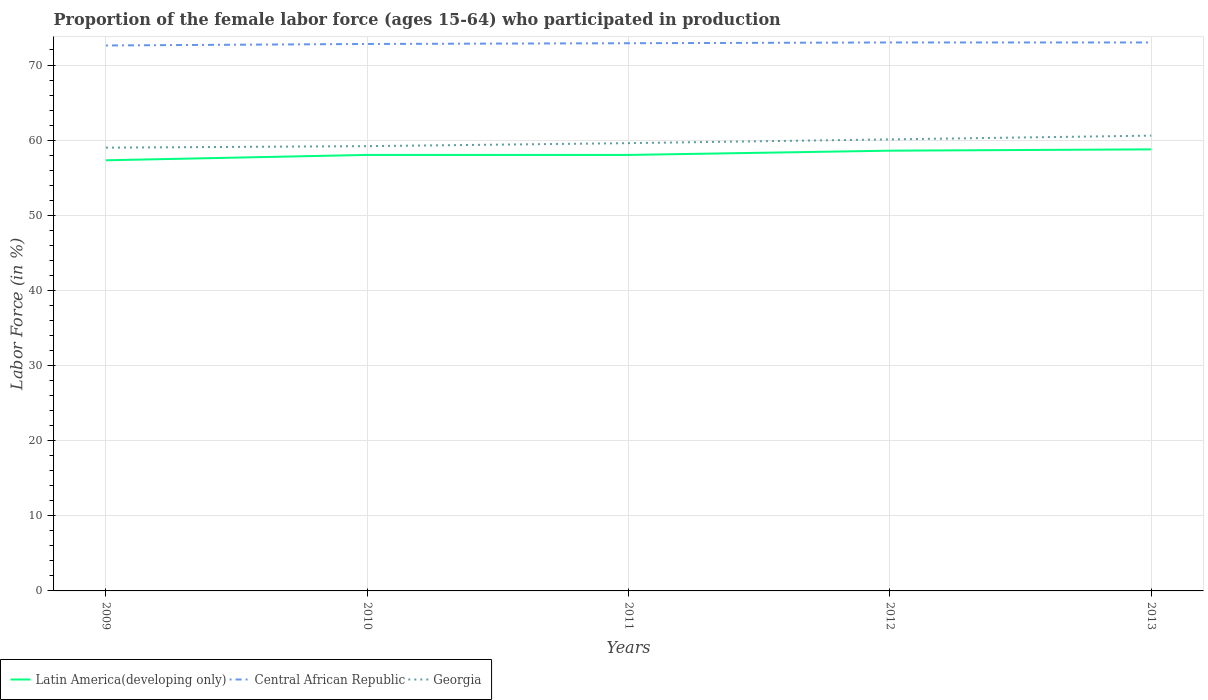Does the line corresponding to Central African Republic intersect with the line corresponding to Georgia?
Your answer should be compact. No. Is the number of lines equal to the number of legend labels?
Make the answer very short. Yes. Across all years, what is the maximum proportion of the female labor force who participated in production in Georgia?
Your answer should be compact. 59. In which year was the proportion of the female labor force who participated in production in Georgia maximum?
Provide a succinct answer. 2009. What is the total proportion of the female labor force who participated in production in Latin America(developing only) in the graph?
Offer a very short reply. -1.28. What is the difference between the highest and the second highest proportion of the female labor force who participated in production in Latin America(developing only)?
Keep it short and to the point. 1.45. How many years are there in the graph?
Provide a succinct answer. 5. Are the values on the major ticks of Y-axis written in scientific E-notation?
Offer a very short reply. No. Does the graph contain any zero values?
Keep it short and to the point. No. How many legend labels are there?
Your answer should be compact. 3. What is the title of the graph?
Your response must be concise. Proportion of the female labor force (ages 15-64) who participated in production. What is the label or title of the Y-axis?
Give a very brief answer. Labor Force (in %). What is the Labor Force (in %) of Latin America(developing only) in 2009?
Provide a succinct answer. 57.32. What is the Labor Force (in %) of Central African Republic in 2009?
Provide a succinct answer. 72.6. What is the Labor Force (in %) of Latin America(developing only) in 2010?
Keep it short and to the point. 58.03. What is the Labor Force (in %) of Central African Republic in 2010?
Provide a succinct answer. 72.8. What is the Labor Force (in %) in Georgia in 2010?
Offer a terse response. 59.2. What is the Labor Force (in %) of Latin America(developing only) in 2011?
Your response must be concise. 58.03. What is the Labor Force (in %) of Central African Republic in 2011?
Your answer should be compact. 72.9. What is the Labor Force (in %) of Georgia in 2011?
Your answer should be very brief. 59.6. What is the Labor Force (in %) in Latin America(developing only) in 2012?
Make the answer very short. 58.6. What is the Labor Force (in %) of Georgia in 2012?
Your answer should be very brief. 60.1. What is the Labor Force (in %) of Latin America(developing only) in 2013?
Make the answer very short. 58.77. What is the Labor Force (in %) in Central African Republic in 2013?
Ensure brevity in your answer.  73. What is the Labor Force (in %) of Georgia in 2013?
Provide a short and direct response. 60.6. Across all years, what is the maximum Labor Force (in %) in Latin America(developing only)?
Your response must be concise. 58.77. Across all years, what is the maximum Labor Force (in %) of Georgia?
Provide a short and direct response. 60.6. Across all years, what is the minimum Labor Force (in %) of Latin America(developing only)?
Provide a short and direct response. 57.32. Across all years, what is the minimum Labor Force (in %) in Central African Republic?
Provide a short and direct response. 72.6. What is the total Labor Force (in %) in Latin America(developing only) in the graph?
Provide a short and direct response. 290.75. What is the total Labor Force (in %) in Central African Republic in the graph?
Ensure brevity in your answer.  364.3. What is the total Labor Force (in %) in Georgia in the graph?
Make the answer very short. 298.5. What is the difference between the Labor Force (in %) in Latin America(developing only) in 2009 and that in 2010?
Your response must be concise. -0.71. What is the difference between the Labor Force (in %) of Latin America(developing only) in 2009 and that in 2011?
Offer a very short reply. -0.71. What is the difference between the Labor Force (in %) in Central African Republic in 2009 and that in 2011?
Ensure brevity in your answer.  -0.3. What is the difference between the Labor Force (in %) in Georgia in 2009 and that in 2011?
Keep it short and to the point. -0.6. What is the difference between the Labor Force (in %) of Latin America(developing only) in 2009 and that in 2012?
Keep it short and to the point. -1.28. What is the difference between the Labor Force (in %) of Georgia in 2009 and that in 2012?
Give a very brief answer. -1.1. What is the difference between the Labor Force (in %) of Latin America(developing only) in 2009 and that in 2013?
Keep it short and to the point. -1.45. What is the difference between the Labor Force (in %) in Central African Republic in 2009 and that in 2013?
Your answer should be very brief. -0.4. What is the difference between the Labor Force (in %) of Georgia in 2009 and that in 2013?
Make the answer very short. -1.6. What is the difference between the Labor Force (in %) of Latin America(developing only) in 2010 and that in 2011?
Provide a short and direct response. 0. What is the difference between the Labor Force (in %) in Central African Republic in 2010 and that in 2011?
Your answer should be compact. -0.1. What is the difference between the Labor Force (in %) of Georgia in 2010 and that in 2011?
Provide a short and direct response. -0.4. What is the difference between the Labor Force (in %) in Latin America(developing only) in 2010 and that in 2012?
Ensure brevity in your answer.  -0.57. What is the difference between the Labor Force (in %) of Latin America(developing only) in 2010 and that in 2013?
Provide a short and direct response. -0.74. What is the difference between the Labor Force (in %) in Central African Republic in 2010 and that in 2013?
Offer a terse response. -0.2. What is the difference between the Labor Force (in %) in Latin America(developing only) in 2011 and that in 2012?
Provide a succinct answer. -0.57. What is the difference between the Labor Force (in %) in Central African Republic in 2011 and that in 2012?
Ensure brevity in your answer.  -0.1. What is the difference between the Labor Force (in %) in Georgia in 2011 and that in 2012?
Make the answer very short. -0.5. What is the difference between the Labor Force (in %) of Latin America(developing only) in 2011 and that in 2013?
Keep it short and to the point. -0.74. What is the difference between the Labor Force (in %) in Georgia in 2011 and that in 2013?
Your response must be concise. -1. What is the difference between the Labor Force (in %) of Latin America(developing only) in 2012 and that in 2013?
Provide a succinct answer. -0.17. What is the difference between the Labor Force (in %) in Central African Republic in 2012 and that in 2013?
Offer a terse response. 0. What is the difference between the Labor Force (in %) in Latin America(developing only) in 2009 and the Labor Force (in %) in Central African Republic in 2010?
Your answer should be very brief. -15.48. What is the difference between the Labor Force (in %) of Latin America(developing only) in 2009 and the Labor Force (in %) of Georgia in 2010?
Offer a very short reply. -1.88. What is the difference between the Labor Force (in %) of Central African Republic in 2009 and the Labor Force (in %) of Georgia in 2010?
Your answer should be very brief. 13.4. What is the difference between the Labor Force (in %) in Latin America(developing only) in 2009 and the Labor Force (in %) in Central African Republic in 2011?
Offer a terse response. -15.58. What is the difference between the Labor Force (in %) of Latin America(developing only) in 2009 and the Labor Force (in %) of Georgia in 2011?
Provide a short and direct response. -2.28. What is the difference between the Labor Force (in %) of Latin America(developing only) in 2009 and the Labor Force (in %) of Central African Republic in 2012?
Your answer should be compact. -15.68. What is the difference between the Labor Force (in %) in Latin America(developing only) in 2009 and the Labor Force (in %) in Georgia in 2012?
Offer a terse response. -2.78. What is the difference between the Labor Force (in %) in Central African Republic in 2009 and the Labor Force (in %) in Georgia in 2012?
Ensure brevity in your answer.  12.5. What is the difference between the Labor Force (in %) of Latin America(developing only) in 2009 and the Labor Force (in %) of Central African Republic in 2013?
Ensure brevity in your answer.  -15.68. What is the difference between the Labor Force (in %) of Latin America(developing only) in 2009 and the Labor Force (in %) of Georgia in 2013?
Offer a very short reply. -3.28. What is the difference between the Labor Force (in %) in Central African Republic in 2009 and the Labor Force (in %) in Georgia in 2013?
Your answer should be very brief. 12. What is the difference between the Labor Force (in %) in Latin America(developing only) in 2010 and the Labor Force (in %) in Central African Republic in 2011?
Keep it short and to the point. -14.87. What is the difference between the Labor Force (in %) of Latin America(developing only) in 2010 and the Labor Force (in %) of Georgia in 2011?
Ensure brevity in your answer.  -1.57. What is the difference between the Labor Force (in %) of Latin America(developing only) in 2010 and the Labor Force (in %) of Central African Republic in 2012?
Offer a very short reply. -14.97. What is the difference between the Labor Force (in %) in Latin America(developing only) in 2010 and the Labor Force (in %) in Georgia in 2012?
Give a very brief answer. -2.07. What is the difference between the Labor Force (in %) in Central African Republic in 2010 and the Labor Force (in %) in Georgia in 2012?
Give a very brief answer. 12.7. What is the difference between the Labor Force (in %) in Latin America(developing only) in 2010 and the Labor Force (in %) in Central African Republic in 2013?
Your answer should be very brief. -14.97. What is the difference between the Labor Force (in %) of Latin America(developing only) in 2010 and the Labor Force (in %) of Georgia in 2013?
Offer a very short reply. -2.57. What is the difference between the Labor Force (in %) of Latin America(developing only) in 2011 and the Labor Force (in %) of Central African Republic in 2012?
Ensure brevity in your answer.  -14.97. What is the difference between the Labor Force (in %) in Latin America(developing only) in 2011 and the Labor Force (in %) in Georgia in 2012?
Provide a short and direct response. -2.07. What is the difference between the Labor Force (in %) in Latin America(developing only) in 2011 and the Labor Force (in %) in Central African Republic in 2013?
Ensure brevity in your answer.  -14.97. What is the difference between the Labor Force (in %) of Latin America(developing only) in 2011 and the Labor Force (in %) of Georgia in 2013?
Ensure brevity in your answer.  -2.57. What is the difference between the Labor Force (in %) in Latin America(developing only) in 2012 and the Labor Force (in %) in Central African Republic in 2013?
Provide a succinct answer. -14.4. What is the difference between the Labor Force (in %) in Latin America(developing only) in 2012 and the Labor Force (in %) in Georgia in 2013?
Offer a terse response. -2. What is the difference between the Labor Force (in %) in Central African Republic in 2012 and the Labor Force (in %) in Georgia in 2013?
Give a very brief answer. 12.4. What is the average Labor Force (in %) of Latin America(developing only) per year?
Provide a short and direct response. 58.15. What is the average Labor Force (in %) of Central African Republic per year?
Give a very brief answer. 72.86. What is the average Labor Force (in %) of Georgia per year?
Your answer should be compact. 59.7. In the year 2009, what is the difference between the Labor Force (in %) in Latin America(developing only) and Labor Force (in %) in Central African Republic?
Ensure brevity in your answer.  -15.28. In the year 2009, what is the difference between the Labor Force (in %) of Latin America(developing only) and Labor Force (in %) of Georgia?
Offer a very short reply. -1.68. In the year 2010, what is the difference between the Labor Force (in %) in Latin America(developing only) and Labor Force (in %) in Central African Republic?
Your answer should be compact. -14.77. In the year 2010, what is the difference between the Labor Force (in %) in Latin America(developing only) and Labor Force (in %) in Georgia?
Your answer should be compact. -1.17. In the year 2010, what is the difference between the Labor Force (in %) in Central African Republic and Labor Force (in %) in Georgia?
Provide a short and direct response. 13.6. In the year 2011, what is the difference between the Labor Force (in %) in Latin America(developing only) and Labor Force (in %) in Central African Republic?
Your answer should be very brief. -14.87. In the year 2011, what is the difference between the Labor Force (in %) of Latin America(developing only) and Labor Force (in %) of Georgia?
Your response must be concise. -1.57. In the year 2011, what is the difference between the Labor Force (in %) in Central African Republic and Labor Force (in %) in Georgia?
Ensure brevity in your answer.  13.3. In the year 2012, what is the difference between the Labor Force (in %) in Latin America(developing only) and Labor Force (in %) in Central African Republic?
Make the answer very short. -14.4. In the year 2012, what is the difference between the Labor Force (in %) in Latin America(developing only) and Labor Force (in %) in Georgia?
Offer a very short reply. -1.5. In the year 2013, what is the difference between the Labor Force (in %) of Latin America(developing only) and Labor Force (in %) of Central African Republic?
Make the answer very short. -14.23. In the year 2013, what is the difference between the Labor Force (in %) of Latin America(developing only) and Labor Force (in %) of Georgia?
Give a very brief answer. -1.83. In the year 2013, what is the difference between the Labor Force (in %) of Central African Republic and Labor Force (in %) of Georgia?
Ensure brevity in your answer.  12.4. What is the ratio of the Labor Force (in %) in Georgia in 2009 to that in 2010?
Your answer should be compact. 1. What is the ratio of the Labor Force (in %) of Central African Republic in 2009 to that in 2011?
Offer a terse response. 1. What is the ratio of the Labor Force (in %) in Georgia in 2009 to that in 2011?
Offer a very short reply. 0.99. What is the ratio of the Labor Force (in %) of Latin America(developing only) in 2009 to that in 2012?
Provide a succinct answer. 0.98. What is the ratio of the Labor Force (in %) in Georgia in 2009 to that in 2012?
Your response must be concise. 0.98. What is the ratio of the Labor Force (in %) in Latin America(developing only) in 2009 to that in 2013?
Offer a terse response. 0.98. What is the ratio of the Labor Force (in %) of Central African Republic in 2009 to that in 2013?
Your answer should be very brief. 0.99. What is the ratio of the Labor Force (in %) in Georgia in 2009 to that in 2013?
Make the answer very short. 0.97. What is the ratio of the Labor Force (in %) of Latin America(developing only) in 2010 to that in 2011?
Keep it short and to the point. 1. What is the ratio of the Labor Force (in %) of Central African Republic in 2010 to that in 2012?
Keep it short and to the point. 1. What is the ratio of the Labor Force (in %) of Latin America(developing only) in 2010 to that in 2013?
Provide a short and direct response. 0.99. What is the ratio of the Labor Force (in %) of Georgia in 2010 to that in 2013?
Your answer should be very brief. 0.98. What is the ratio of the Labor Force (in %) in Latin America(developing only) in 2011 to that in 2012?
Ensure brevity in your answer.  0.99. What is the ratio of the Labor Force (in %) of Central African Republic in 2011 to that in 2012?
Ensure brevity in your answer.  1. What is the ratio of the Labor Force (in %) of Latin America(developing only) in 2011 to that in 2013?
Keep it short and to the point. 0.99. What is the ratio of the Labor Force (in %) in Central African Republic in 2011 to that in 2013?
Provide a short and direct response. 1. What is the ratio of the Labor Force (in %) in Georgia in 2011 to that in 2013?
Make the answer very short. 0.98. What is the ratio of the Labor Force (in %) in Latin America(developing only) in 2012 to that in 2013?
Ensure brevity in your answer.  1. What is the ratio of the Labor Force (in %) in Central African Republic in 2012 to that in 2013?
Ensure brevity in your answer.  1. What is the difference between the highest and the second highest Labor Force (in %) in Latin America(developing only)?
Your response must be concise. 0.17. What is the difference between the highest and the lowest Labor Force (in %) of Latin America(developing only)?
Ensure brevity in your answer.  1.45. 